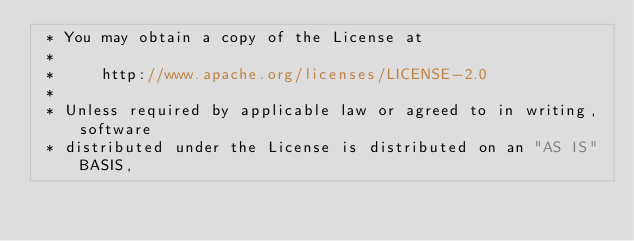<code> <loc_0><loc_0><loc_500><loc_500><_Java_> * You may obtain a copy of the License at
 *
 *     http://www.apache.org/licenses/LICENSE-2.0
 *
 * Unless required by applicable law or agreed to in writing, software
 * distributed under the License is distributed on an "AS IS" BASIS,</code> 